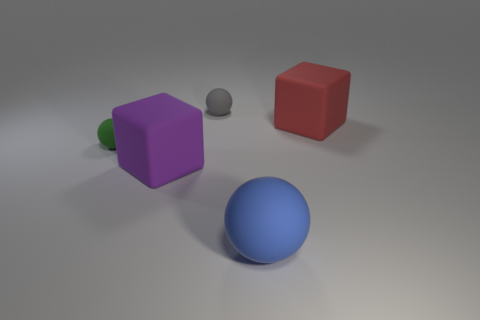Subtract all blue rubber balls. How many balls are left? 2 Add 2 matte cubes. How many objects exist? 7 Subtract all blue spheres. How many spheres are left? 2 Subtract all cubes. How many objects are left? 3 Add 4 balls. How many balls are left? 7 Add 2 large green shiny cubes. How many large green shiny cubes exist? 2 Subtract 1 purple cubes. How many objects are left? 4 Subtract 2 blocks. How many blocks are left? 0 Subtract all red blocks. Subtract all yellow cylinders. How many blocks are left? 1 Subtract all red spheres. How many red blocks are left? 1 